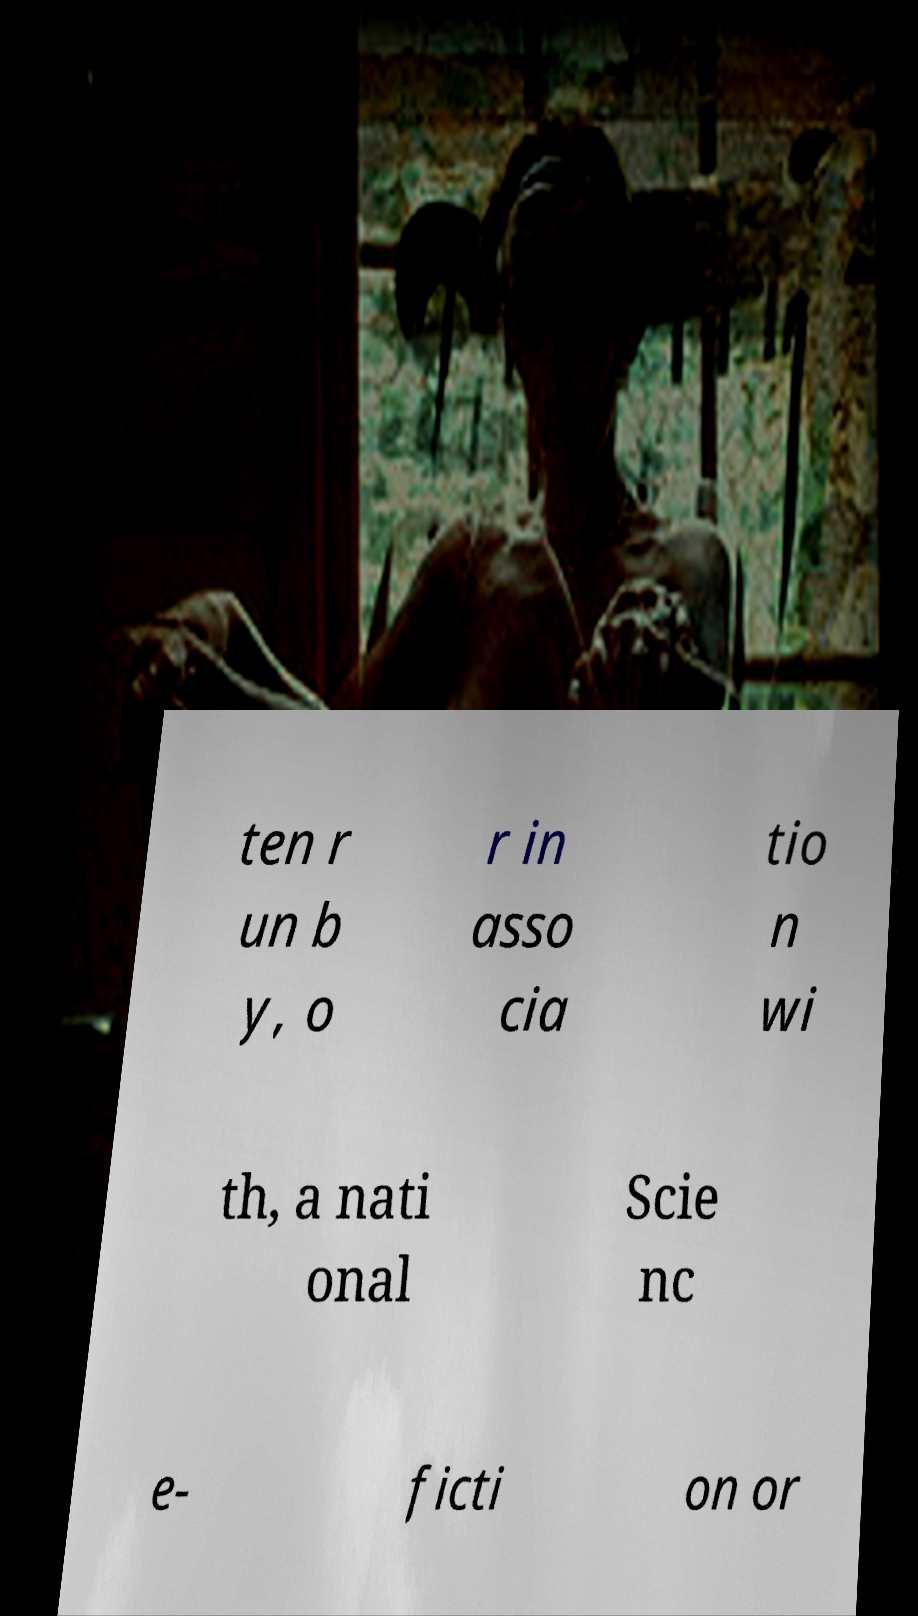Can you read and provide the text displayed in the image?This photo seems to have some interesting text. Can you extract and type it out for me? ten r un b y, o r in asso cia tio n wi th, a nati onal Scie nc e- ficti on or 